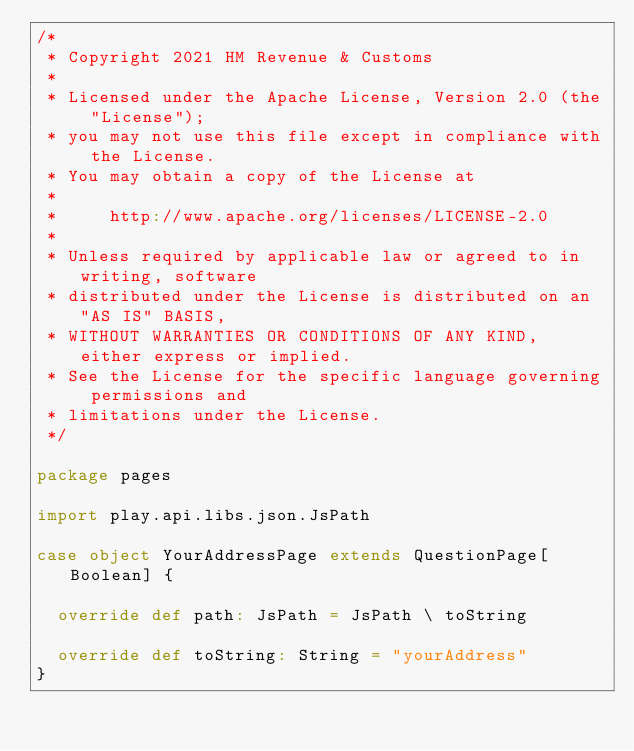<code> <loc_0><loc_0><loc_500><loc_500><_Scala_>/*
 * Copyright 2021 HM Revenue & Customs
 *
 * Licensed under the Apache License, Version 2.0 (the "License");
 * you may not use this file except in compliance with the License.
 * You may obtain a copy of the License at
 *
 *     http://www.apache.org/licenses/LICENSE-2.0
 *
 * Unless required by applicable law or agreed to in writing, software
 * distributed under the License is distributed on an "AS IS" BASIS,
 * WITHOUT WARRANTIES OR CONDITIONS OF ANY KIND, either express or implied.
 * See the License for the specific language governing permissions and
 * limitations under the License.
 */

package pages

import play.api.libs.json.JsPath

case object YourAddressPage extends QuestionPage[Boolean] {

  override def path: JsPath = JsPath \ toString

  override def toString: String = "yourAddress"
}
</code> 